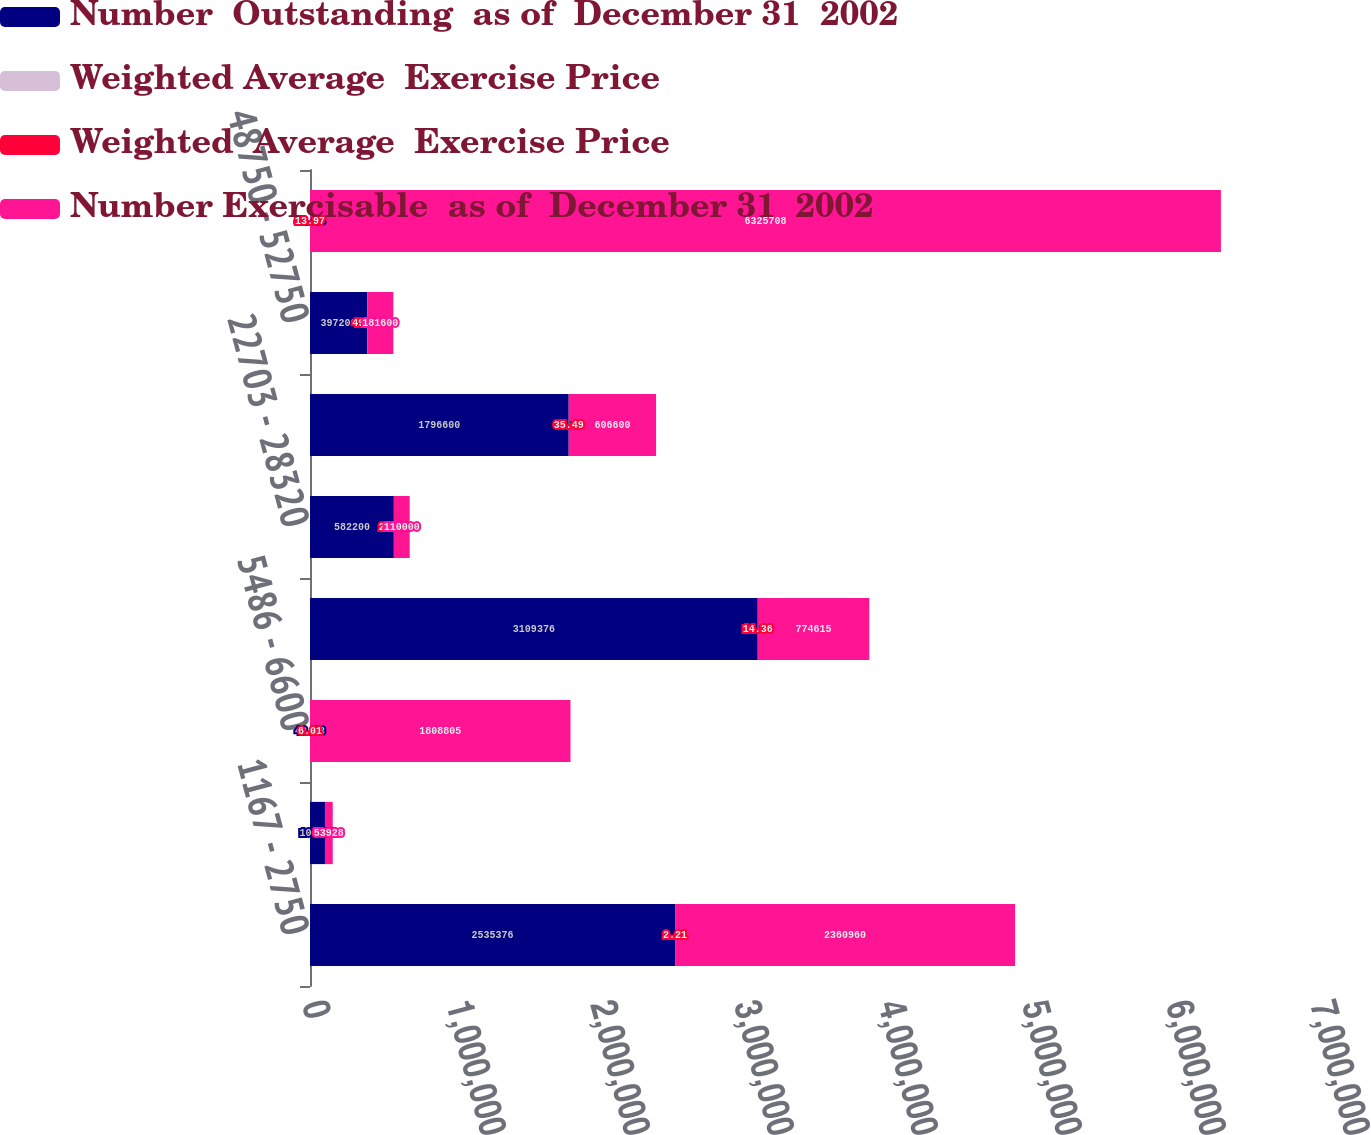<chart> <loc_0><loc_0><loc_500><loc_500><stacked_bar_chart><ecel><fcel>1167 - 2750<fcel>3000 - 3434<fcel>5486 - 6600<fcel>10203 - 19180<fcel>22703 - 28320<fcel>32420 - 39500<fcel>48750 - 52750<fcel>11667 - 79000<nl><fcel>Number  Outstanding  as of  December 31  2002<fcel>2.53538e+06<fcel>103864<fcel>42.43<fcel>3.10938e+06<fcel>582200<fcel>1.7966e+06<fcel>397200<fcel>42.43<nl><fcel>Weighted Average  Exercise Price<fcel>3.74<fcel>4.8<fcel>6.08<fcel>6.28<fcel>7.96<fcel>6.31<fcel>7.12<fcel>5.98<nl><fcel>Weighted  Average  Exercise Price<fcel>2.21<fcel>3.02<fcel>6.01<fcel>14.36<fcel>25.12<fcel>35.49<fcel>49.37<fcel>13.97<nl><fcel>Number Exercisable  as of  December 31  2002<fcel>2.36096e+06<fcel>53928<fcel>1.8088e+06<fcel>774615<fcel>110000<fcel>606600<fcel>181600<fcel>6.32571e+06<nl></chart> 